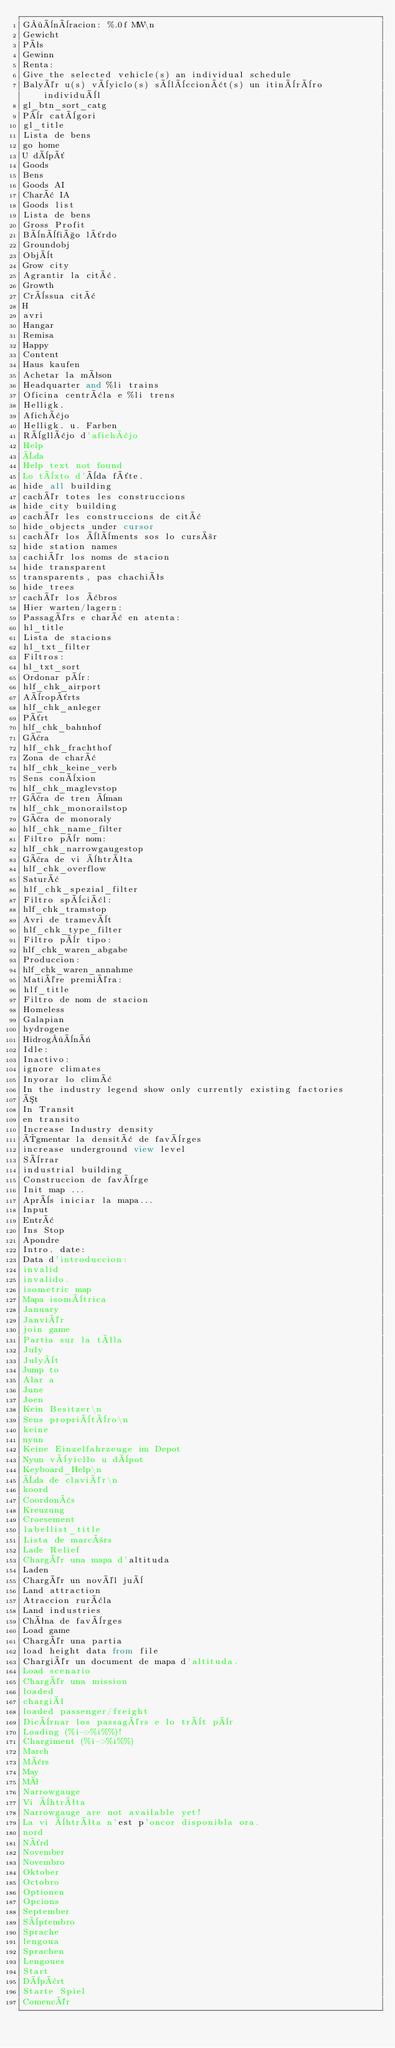<code> <loc_0><loc_0><loc_500><loc_500><_SQL_>G·ènèracion: %.0f MW\n
Gewicht
Pês
Gewinn
Renta:
Give the selected vehicle(s) an individual schedule
Balyér u(s) vèyiclo(s) sèlèccionât(s) un itinèrèro individuèl
gl_btn_sort_catg
Pèr catègori
gl_title
Lista de bens
go home
U dèpô
Goods
Bens
Goods AI
Charâ IA
Goods list
Lista de bens
Gross Profit
Bènèfiço lôrdo
Groundobj
Objèt
Grow city
Agrantir la citâ.
Growth
Crèssua citâ
H
avri
Hangar
Remisa
Happy
Content
Haus kaufen
Achetar la mêson
Headquarter and %li trains
Oficina centrâla e %li trens
Helligk.
Afichâjo
Helligk. u. Farben
Règllâjo d'afichâjo
Help
Èda
Help text not found
Lo tèxto d'èda fôte.
hide all building
cachér totes les construccions
hide city building
cachér les construccions de citâ
hide objects under cursor
cachér los èlèments sos lo cursòr
hide station names
cachiér los noms de stacion
hide transparent
transparents, pas chachiês
hide trees
cachér los âbros
Hier warten/lagern:
Passagérs e charâ en atenta:
hl_title
Lista de stacions
hl_txt_filter
Filtros:
hl_txt_sort
Ordonar pèr:
hlf_chk_airport
Aèropôrts
hlf_chk_anleger
Pôrt
hlf_chk_bahnhof
Gâra
hlf_chk_frachthof
Zona de charâ
hlf_chk_keine_verb
Sens conèxion
hlf_chk_maglevstop
Gâra de tren èman
hlf_chk_monorailstop
Gâra de monoraly
hlf_chk_name_filter
Filtro pèr nom:
hlf_chk_narrowgaugestop
Gâra de vi èhtrêta
hlf_chk_overflow
Saturâ
hlf_chk_spezial_filter
Filtro spèciâl:
hlf_chk_tramstop
Avri de tramevèt
hlf_chk_type_filter
Filtro pèr tipo:
hlf_chk_waren_abgabe
Produccion:
hlf_chk_waren_annahme
Matiére premiéra:
hlf_title
Filtro de nom de stacion
Homeless
Galapian
hydrogene
Hidrog·ènë
Idle:
Inactivo:
ignore climates
Inyorar lo climâ
In the industry legend show only currently existing factories
Ót
In Transit
en transito
Increase Industry density
Ôgmentar la densitâ de favèrges
increase underground view level
Sèrrar
industrial building
Construccion de favèrge
Init map ...
Après iniciar la mapa...
Input
Entrâ
Ins Stop
Apondre
Intro. date:
Data d'introduccion:
invalid
invalido.
isometric map
Mapa isomètrica
January
Janviér
join game
Partia sur la têla
July
Julyèt
Jump to
Alar a
June
Joen
Kein Besitzer\n
Sens propriètèro\n
keine
nyun
Keine Einzelfahrzeuge im Depot
Nyun vèyicllo u dèpot
Keyboard_Help\n
Èda de claviér\n
koord
Coordonâs
Kreuzung
Croesement
labellist_title
Lista de marcòrs
Lade Relief
Chargér una mapa d'altituda
Laden
Chargér un novél juè
Land attraction
Atraccion rurâla
Land industries
Chêna de favèrges
Load game
Chargér una partia
load height data from file
Chargiér un document de mapa d'altituda.
Load scenario
Chargér una mission
loaded
chargiê
loaded passenger/freight
Dicèrnar los passagérs e lo trèt pèr
Loading (%i->%i%%)!
Chargiment (%i->%i%%)
March
Mârs
May
Mê
Narrowgauge
Vi èhtrêta
Narrowgauge are not available yet!
La vi èhtrêta n'est p'oncor disponibla ora.
nord
Nôrd
November
Novembro
Oktober
Octobro
Optionen
Opcions
September
Sèptembro
Sprache
lengoua
Sprachen
Lengoues
Start
Dèpârt
Starte Spiel
Comencér
</code> 